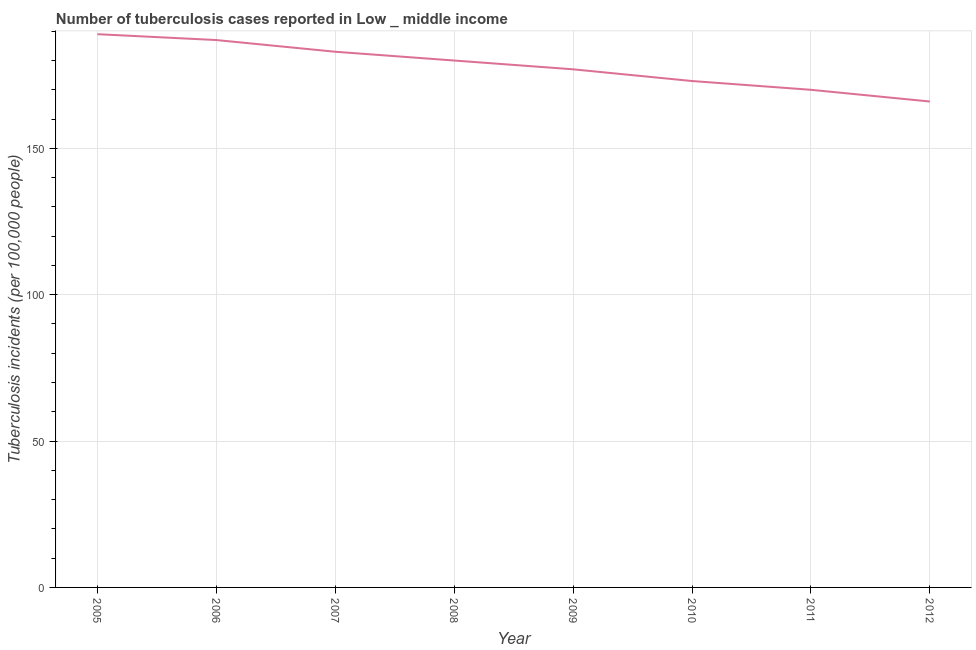What is the number of tuberculosis incidents in 2012?
Provide a succinct answer. 166. Across all years, what is the maximum number of tuberculosis incidents?
Your answer should be compact. 189. Across all years, what is the minimum number of tuberculosis incidents?
Offer a very short reply. 166. In which year was the number of tuberculosis incidents maximum?
Give a very brief answer. 2005. What is the sum of the number of tuberculosis incidents?
Your response must be concise. 1425. What is the difference between the number of tuberculosis incidents in 2006 and 2011?
Offer a terse response. 17. What is the average number of tuberculosis incidents per year?
Ensure brevity in your answer.  178.12. What is the median number of tuberculosis incidents?
Offer a terse response. 178.5. Do a majority of the years between 2009 and 2006 (inclusive) have number of tuberculosis incidents greater than 110 ?
Give a very brief answer. Yes. What is the ratio of the number of tuberculosis incidents in 2007 to that in 2010?
Provide a short and direct response. 1.06. What is the difference between the highest and the lowest number of tuberculosis incidents?
Offer a terse response. 23. In how many years, is the number of tuberculosis incidents greater than the average number of tuberculosis incidents taken over all years?
Give a very brief answer. 4. Does the number of tuberculosis incidents monotonically increase over the years?
Keep it short and to the point. No. How many years are there in the graph?
Make the answer very short. 8. What is the difference between two consecutive major ticks on the Y-axis?
Provide a short and direct response. 50. Does the graph contain any zero values?
Your answer should be compact. No. What is the title of the graph?
Provide a succinct answer. Number of tuberculosis cases reported in Low _ middle income. What is the label or title of the Y-axis?
Provide a succinct answer. Tuberculosis incidents (per 100,0 people). What is the Tuberculosis incidents (per 100,000 people) in 2005?
Provide a short and direct response. 189. What is the Tuberculosis incidents (per 100,000 people) of 2006?
Provide a short and direct response. 187. What is the Tuberculosis incidents (per 100,000 people) of 2007?
Your answer should be compact. 183. What is the Tuberculosis incidents (per 100,000 people) in 2008?
Provide a succinct answer. 180. What is the Tuberculosis incidents (per 100,000 people) of 2009?
Your answer should be very brief. 177. What is the Tuberculosis incidents (per 100,000 people) in 2010?
Offer a terse response. 173. What is the Tuberculosis incidents (per 100,000 people) in 2011?
Your answer should be very brief. 170. What is the Tuberculosis incidents (per 100,000 people) in 2012?
Provide a succinct answer. 166. What is the difference between the Tuberculosis incidents (per 100,000 people) in 2005 and 2007?
Give a very brief answer. 6. What is the difference between the Tuberculosis incidents (per 100,000 people) in 2005 and 2009?
Your response must be concise. 12. What is the difference between the Tuberculosis incidents (per 100,000 people) in 2005 and 2010?
Your response must be concise. 16. What is the difference between the Tuberculosis incidents (per 100,000 people) in 2005 and 2011?
Offer a terse response. 19. What is the difference between the Tuberculosis incidents (per 100,000 people) in 2005 and 2012?
Your answer should be compact. 23. What is the difference between the Tuberculosis incidents (per 100,000 people) in 2006 and 2007?
Make the answer very short. 4. What is the difference between the Tuberculosis incidents (per 100,000 people) in 2006 and 2010?
Make the answer very short. 14. What is the difference between the Tuberculosis incidents (per 100,000 people) in 2006 and 2012?
Provide a short and direct response. 21. What is the difference between the Tuberculosis incidents (per 100,000 people) in 2007 and 2008?
Your response must be concise. 3. What is the difference between the Tuberculosis incidents (per 100,000 people) in 2007 and 2010?
Make the answer very short. 10. What is the difference between the Tuberculosis incidents (per 100,000 people) in 2007 and 2011?
Keep it short and to the point. 13. What is the difference between the Tuberculosis incidents (per 100,000 people) in 2007 and 2012?
Provide a succinct answer. 17. What is the difference between the Tuberculosis incidents (per 100,000 people) in 2008 and 2009?
Keep it short and to the point. 3. What is the difference between the Tuberculosis incidents (per 100,000 people) in 2008 and 2012?
Your answer should be compact. 14. What is the difference between the Tuberculosis incidents (per 100,000 people) in 2009 and 2012?
Provide a succinct answer. 11. What is the difference between the Tuberculosis incidents (per 100,000 people) in 2010 and 2012?
Give a very brief answer. 7. What is the ratio of the Tuberculosis incidents (per 100,000 people) in 2005 to that in 2007?
Provide a succinct answer. 1.03. What is the ratio of the Tuberculosis incidents (per 100,000 people) in 2005 to that in 2008?
Offer a very short reply. 1.05. What is the ratio of the Tuberculosis incidents (per 100,000 people) in 2005 to that in 2009?
Give a very brief answer. 1.07. What is the ratio of the Tuberculosis incidents (per 100,000 people) in 2005 to that in 2010?
Offer a very short reply. 1.09. What is the ratio of the Tuberculosis incidents (per 100,000 people) in 2005 to that in 2011?
Provide a succinct answer. 1.11. What is the ratio of the Tuberculosis incidents (per 100,000 people) in 2005 to that in 2012?
Ensure brevity in your answer.  1.14. What is the ratio of the Tuberculosis incidents (per 100,000 people) in 2006 to that in 2007?
Ensure brevity in your answer.  1.02. What is the ratio of the Tuberculosis incidents (per 100,000 people) in 2006 to that in 2008?
Provide a succinct answer. 1.04. What is the ratio of the Tuberculosis incidents (per 100,000 people) in 2006 to that in 2009?
Your response must be concise. 1.06. What is the ratio of the Tuberculosis incidents (per 100,000 people) in 2006 to that in 2010?
Your answer should be compact. 1.08. What is the ratio of the Tuberculosis incidents (per 100,000 people) in 2006 to that in 2012?
Offer a terse response. 1.13. What is the ratio of the Tuberculosis incidents (per 100,000 people) in 2007 to that in 2008?
Offer a terse response. 1.02. What is the ratio of the Tuberculosis incidents (per 100,000 people) in 2007 to that in 2009?
Your answer should be very brief. 1.03. What is the ratio of the Tuberculosis incidents (per 100,000 people) in 2007 to that in 2010?
Keep it short and to the point. 1.06. What is the ratio of the Tuberculosis incidents (per 100,000 people) in 2007 to that in 2011?
Make the answer very short. 1.08. What is the ratio of the Tuberculosis incidents (per 100,000 people) in 2007 to that in 2012?
Your answer should be compact. 1.1. What is the ratio of the Tuberculosis incidents (per 100,000 people) in 2008 to that in 2011?
Your response must be concise. 1.06. What is the ratio of the Tuberculosis incidents (per 100,000 people) in 2008 to that in 2012?
Offer a very short reply. 1.08. What is the ratio of the Tuberculosis incidents (per 100,000 people) in 2009 to that in 2011?
Give a very brief answer. 1.04. What is the ratio of the Tuberculosis incidents (per 100,000 people) in 2009 to that in 2012?
Your answer should be compact. 1.07. What is the ratio of the Tuberculosis incidents (per 100,000 people) in 2010 to that in 2011?
Your response must be concise. 1.02. What is the ratio of the Tuberculosis incidents (per 100,000 people) in 2010 to that in 2012?
Your response must be concise. 1.04. 